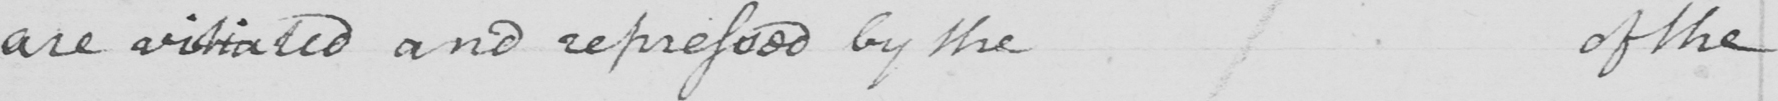Please provide the text content of this handwritten line. are vitiated and repressed by the of the 